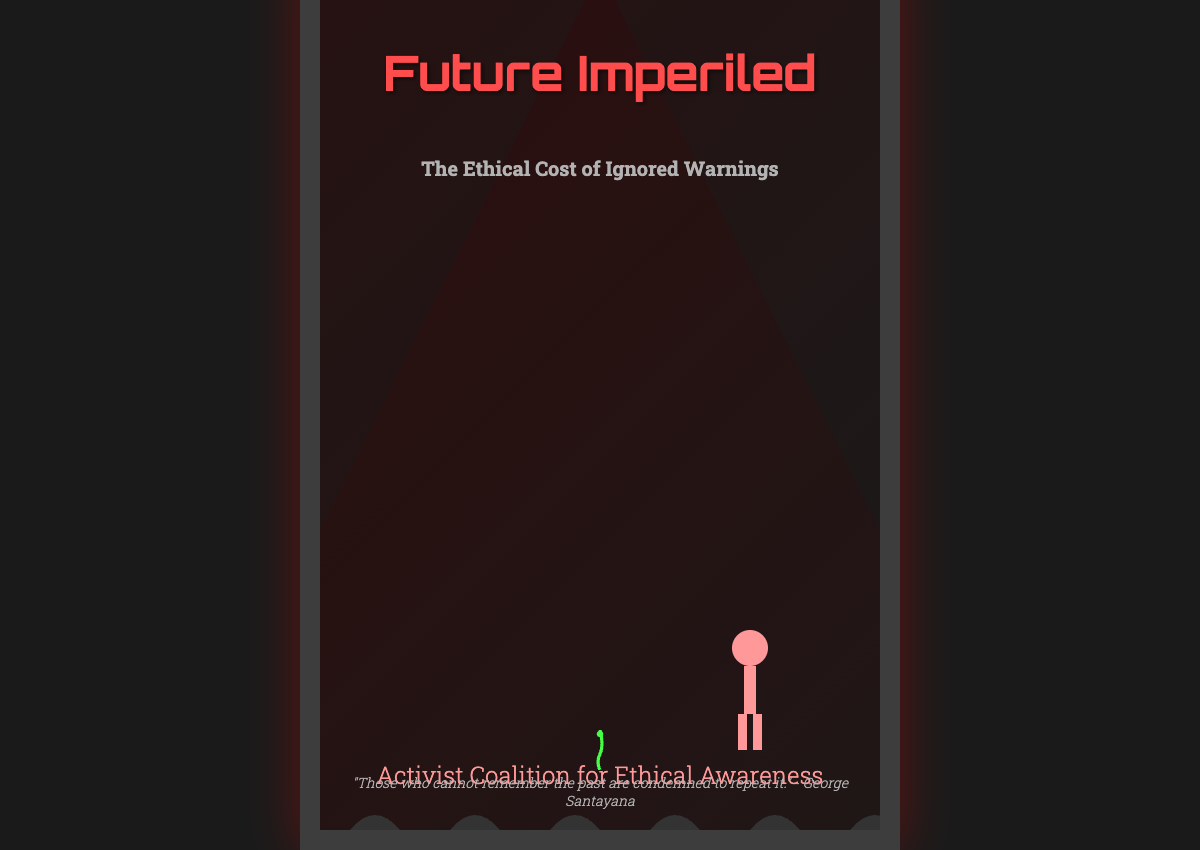What is the book title? The title of the book is prominently displayed at the top of the cover.
Answer: Future Imperiled What is the subtitle of the book? The subtitle is located just below the title on the cover.
Answer: The Ethical Cost of Ignored Warnings Who is the author of the book? The author's name is found at the bottom of the cover.
Answer: Activist Coalition for Ethical Awareness What color scheme is predominantly used on the cover? The cover's background and text colors indicate a specific theme.
Answer: Dark colors What quote is featured on the cover? The quote is displayed at the bottom of the cover in italic font.
Answer: "Those who cannot remember the past are condemned to repeat it." - George Santayana What positive elements are depicted on the cover? The cover illustrates elements that symbolize hope amidst a dystopian background.
Answer: Seedlings Where are the human figures illustrated on the cover? The positioning of the human figure contributes to the visual narrative of the cover.
Answer: Bottom right What does the background of the cover depict? The background imagery conveys a sense of the book's dystopian theme.
Answer: Futuristic landscape How does the design of the cover convey emotion? The use of colors and imagery suggests a specific emotional response related to the content.
Answer: Stark contrast 